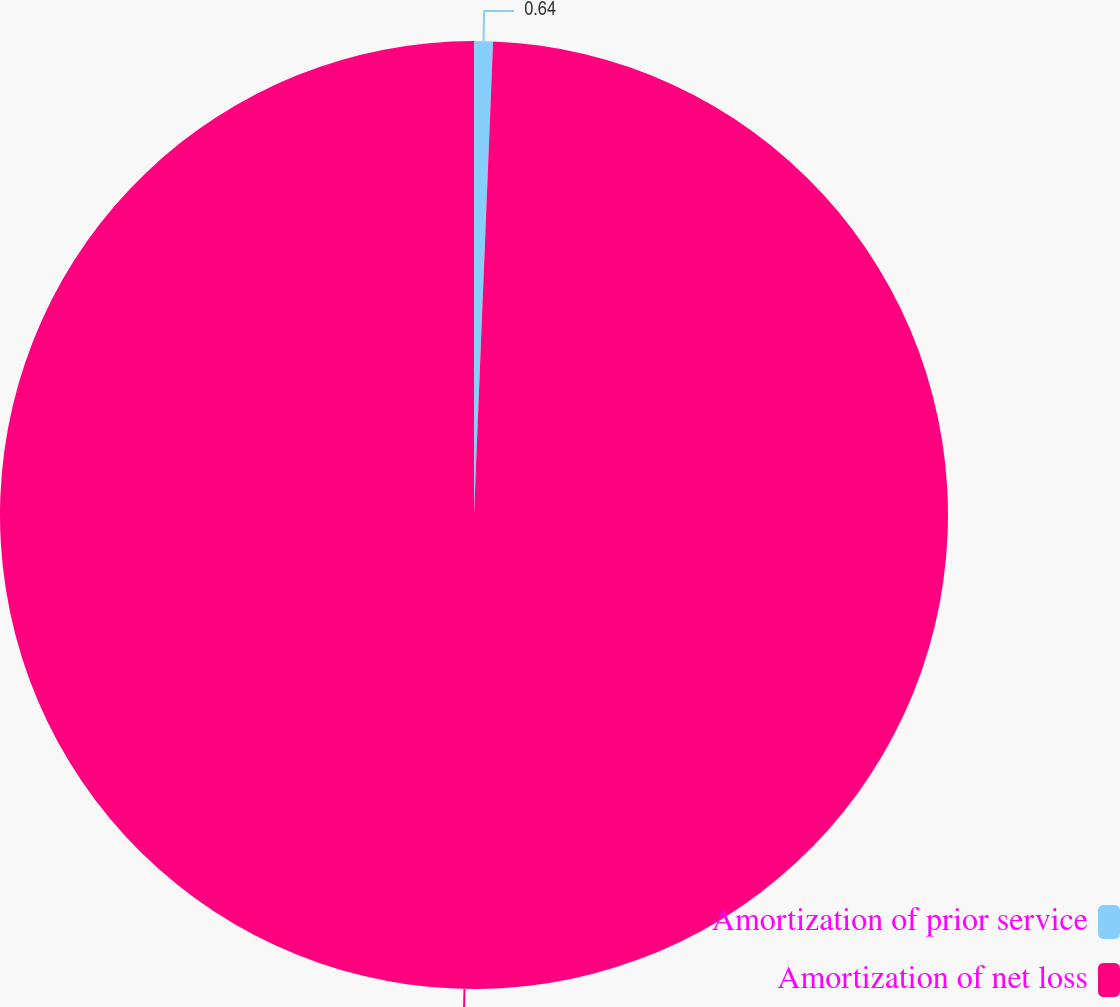<chart> <loc_0><loc_0><loc_500><loc_500><pie_chart><fcel>Amortization of prior service<fcel>Amortization of net loss<nl><fcel>0.64%<fcel>99.36%<nl></chart> 